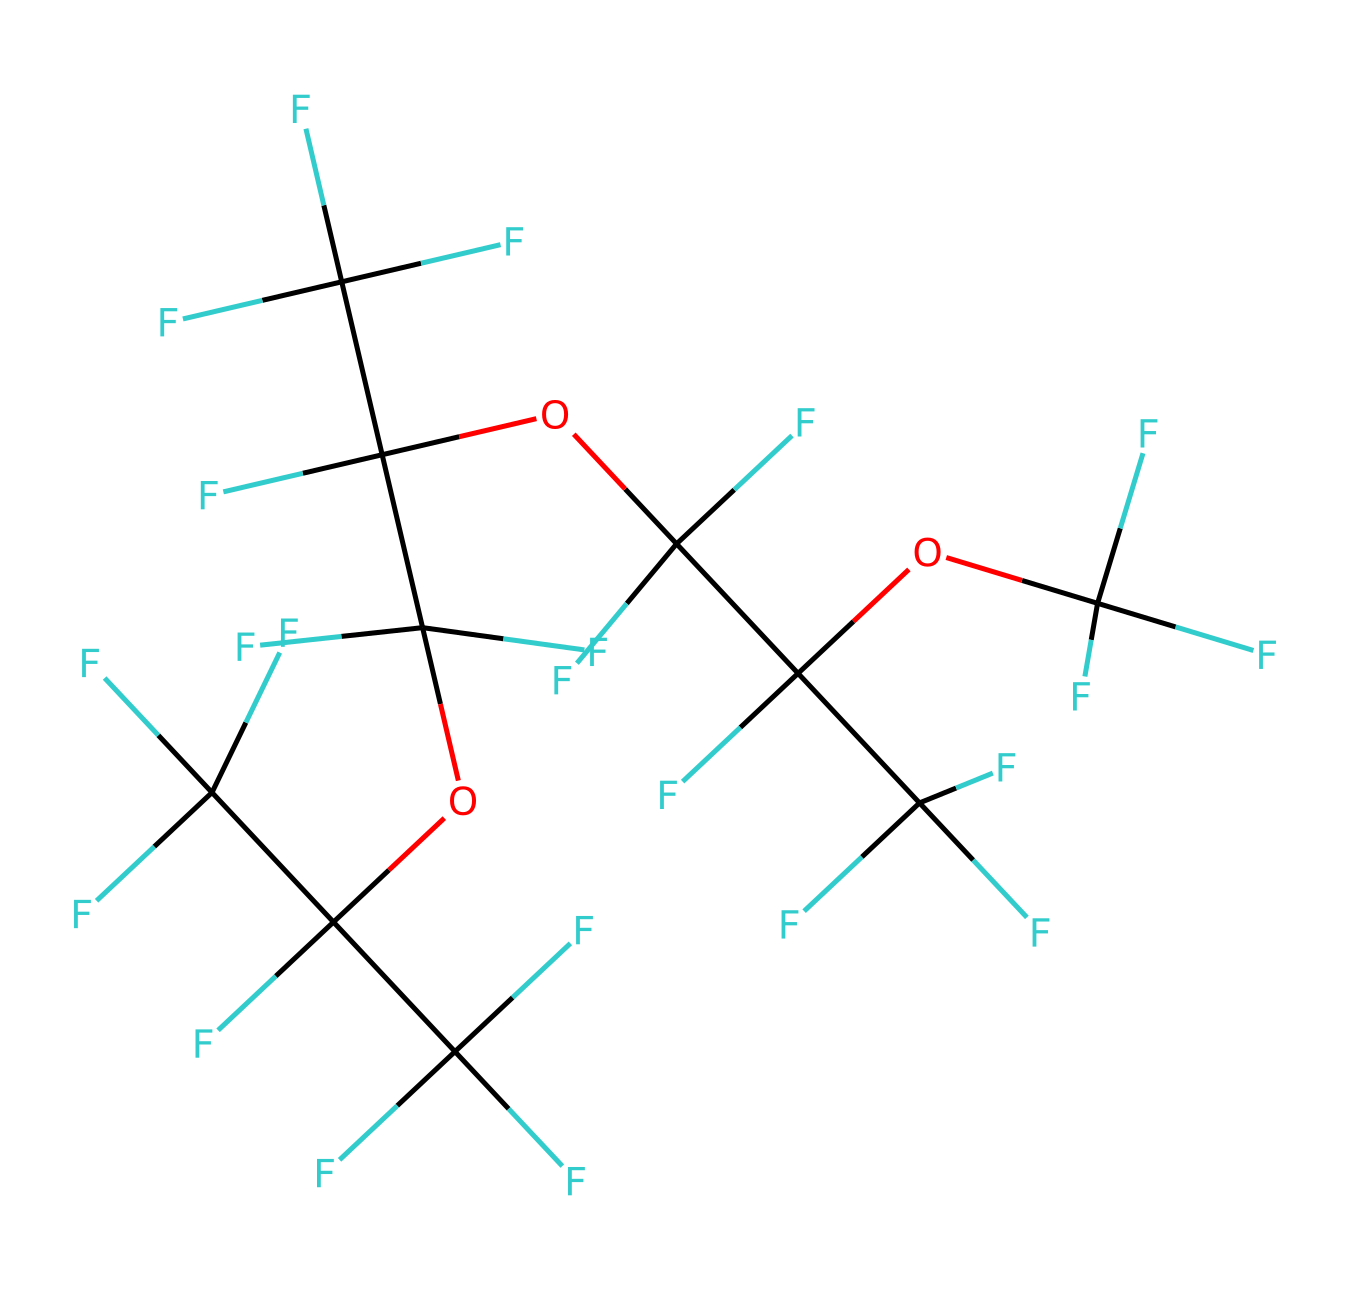What is the molecular formula for this compound? To determine the molecular formula, we count the different atoms present in the SMILES. The structure includes carbon (C), fluorine (F), and oxygen (O) atoms. Counting them shows there are 15 carbon, 30 fluorine, and 6 oxygen atoms. Thus, the molecular formula can be written as C15F30O6.
Answer: C15F30O6 How many oxygen atoms are in the structure? By analyzing the SMILES, we can identify the parts of the molecule that include oxygen; specifically, there are three ether groups indicated by OC links. Each ether group contains one oxygen atom, yielding a total of six oxygen atoms present in the structure.
Answer: 6 What type of compounds does this lubricant represent? The presence of multiple carbon-fluorine bonds and the ether functional groups suggests that this is a synthetic fluorinated lubricant. Such compounds are known for their excellent thermal stability and low friction properties, making them ideal for precision applications.
Answer: synthetic fluorinated lubricant How many carbon atoms are in the main chain of this molecule? By examining the SMILES, we can see the repeating units that primarily consist of carbon atoms. Counting from the start to the end of the chain reveals a total of 15 carbon atoms.
Answer: 15 What property of this compound makes it suitable for precision scientific instruments? The high fluorine content and stable ether linkages contribute to low volatility and excellent lubricity. These properties reduce wear and maintain performance under varying pressures and temperatures, making it suitable for precision instruments.
Answer: low volatility Does this lubricant have a reactive group? The analysis of the molecular structure shows multiple ether linkages (–OC–), which are generally non-reactive under standard conditions. The lack of functional groups like amines or acids indicates limited reactivity, making it chemically stable.
Answer: no 